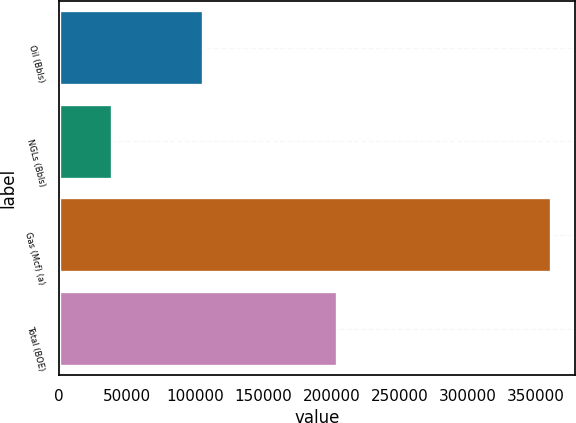Convert chart to OTSL. <chart><loc_0><loc_0><loc_500><loc_500><bar_chart><fcel>Oil (Bbls)<fcel>NGLs (Bbls)<fcel>Gas (Mcf) (a)<fcel>Total (BOE)<nl><fcel>105347<fcel>38592<fcel>360662<fcel>204050<nl></chart> 